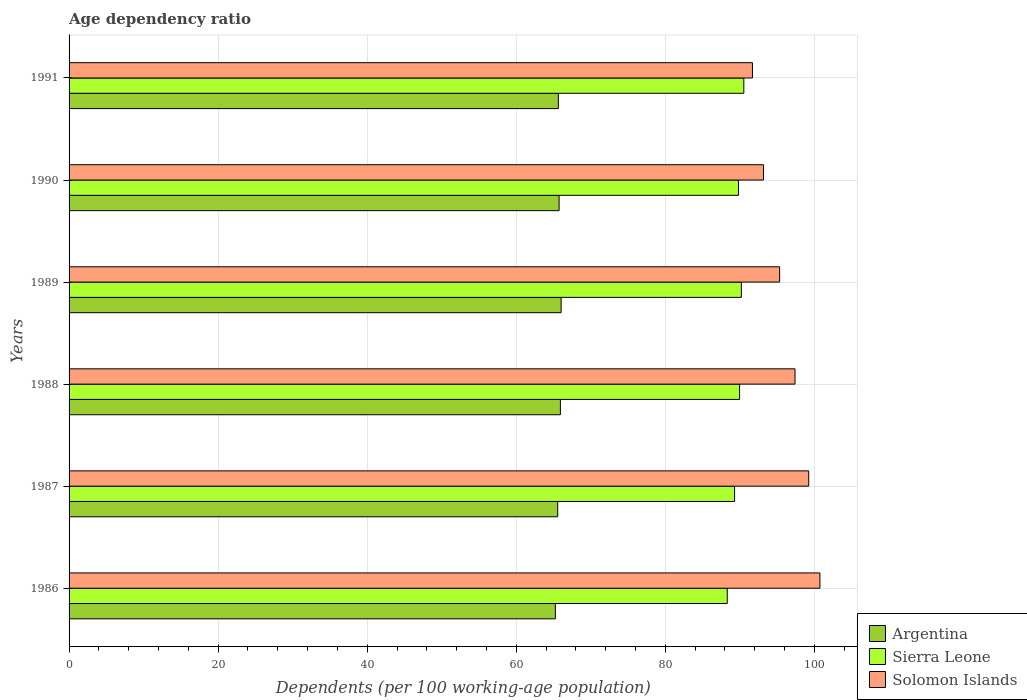How many different coloured bars are there?
Your answer should be compact. 3. How many groups of bars are there?
Ensure brevity in your answer.  6. Are the number of bars on each tick of the Y-axis equal?
Your answer should be compact. Yes. How many bars are there on the 2nd tick from the bottom?
Offer a terse response. 3. What is the label of the 3rd group of bars from the top?
Ensure brevity in your answer.  1989. What is the age dependency ratio in in Sierra Leone in 1990?
Offer a terse response. 89.81. Across all years, what is the maximum age dependency ratio in in Solomon Islands?
Offer a very short reply. 100.74. Across all years, what is the minimum age dependency ratio in in Argentina?
Offer a very short reply. 65.25. In which year was the age dependency ratio in in Sierra Leone minimum?
Provide a short and direct response. 1986. What is the total age dependency ratio in in Solomon Islands in the graph?
Your answer should be very brief. 577.56. What is the difference between the age dependency ratio in in Argentina in 1987 and that in 1990?
Your answer should be compact. -0.19. What is the difference between the age dependency ratio in in Argentina in 1990 and the age dependency ratio in in Sierra Leone in 1988?
Make the answer very short. -24.22. What is the average age dependency ratio in in Argentina per year?
Your answer should be compact. 65.69. In the year 1990, what is the difference between the age dependency ratio in in Argentina and age dependency ratio in in Solomon Islands?
Keep it short and to the point. -27.42. What is the ratio of the age dependency ratio in in Argentina in 1986 to that in 1990?
Provide a short and direct response. 0.99. What is the difference between the highest and the second highest age dependency ratio in in Argentina?
Your answer should be compact. 0.1. What is the difference between the highest and the lowest age dependency ratio in in Sierra Leone?
Keep it short and to the point. 2.22. Is the sum of the age dependency ratio in in Sierra Leone in 1987 and 1991 greater than the maximum age dependency ratio in in Solomon Islands across all years?
Ensure brevity in your answer.  Yes. What does the 2nd bar from the top in 1989 represents?
Your answer should be very brief. Sierra Leone. How many bars are there?
Give a very brief answer. 18. Are all the bars in the graph horizontal?
Provide a short and direct response. Yes. How many years are there in the graph?
Give a very brief answer. 6. What is the difference between two consecutive major ticks on the X-axis?
Ensure brevity in your answer.  20. Does the graph contain any zero values?
Provide a succinct answer. No. Does the graph contain grids?
Provide a short and direct response. Yes. Where does the legend appear in the graph?
Ensure brevity in your answer.  Bottom right. How many legend labels are there?
Give a very brief answer. 3. How are the legend labels stacked?
Give a very brief answer. Vertical. What is the title of the graph?
Your answer should be compact. Age dependency ratio. Does "Syrian Arab Republic" appear as one of the legend labels in the graph?
Your answer should be very brief. No. What is the label or title of the X-axis?
Your answer should be very brief. Dependents (per 100 working-age population). What is the Dependents (per 100 working-age population) in Argentina in 1986?
Your response must be concise. 65.25. What is the Dependents (per 100 working-age population) of Sierra Leone in 1986?
Make the answer very short. 88.3. What is the Dependents (per 100 working-age population) in Solomon Islands in 1986?
Your response must be concise. 100.74. What is the Dependents (per 100 working-age population) in Argentina in 1987?
Your answer should be compact. 65.56. What is the Dependents (per 100 working-age population) in Sierra Leone in 1987?
Offer a terse response. 89.29. What is the Dependents (per 100 working-age population) of Solomon Islands in 1987?
Provide a succinct answer. 99.23. What is the Dependents (per 100 working-age population) of Argentina in 1988?
Ensure brevity in your answer.  65.92. What is the Dependents (per 100 working-age population) in Sierra Leone in 1988?
Offer a very short reply. 89.96. What is the Dependents (per 100 working-age population) in Solomon Islands in 1988?
Ensure brevity in your answer.  97.4. What is the Dependents (per 100 working-age population) of Argentina in 1989?
Your response must be concise. 66.02. What is the Dependents (per 100 working-age population) of Sierra Leone in 1989?
Make the answer very short. 90.2. What is the Dependents (per 100 working-age population) of Solomon Islands in 1989?
Your answer should be compact. 95.33. What is the Dependents (per 100 working-age population) of Argentina in 1990?
Ensure brevity in your answer.  65.75. What is the Dependents (per 100 working-age population) in Sierra Leone in 1990?
Your answer should be compact. 89.81. What is the Dependents (per 100 working-age population) in Solomon Islands in 1990?
Your answer should be compact. 93.17. What is the Dependents (per 100 working-age population) in Argentina in 1991?
Your answer should be compact. 65.64. What is the Dependents (per 100 working-age population) in Sierra Leone in 1991?
Ensure brevity in your answer.  90.53. What is the Dependents (per 100 working-age population) of Solomon Islands in 1991?
Your response must be concise. 91.69. Across all years, what is the maximum Dependents (per 100 working-age population) of Argentina?
Provide a short and direct response. 66.02. Across all years, what is the maximum Dependents (per 100 working-age population) of Sierra Leone?
Your answer should be compact. 90.53. Across all years, what is the maximum Dependents (per 100 working-age population) of Solomon Islands?
Provide a short and direct response. 100.74. Across all years, what is the minimum Dependents (per 100 working-age population) in Argentina?
Your answer should be compact. 65.25. Across all years, what is the minimum Dependents (per 100 working-age population) in Sierra Leone?
Your answer should be very brief. 88.3. Across all years, what is the minimum Dependents (per 100 working-age population) in Solomon Islands?
Offer a very short reply. 91.69. What is the total Dependents (per 100 working-age population) in Argentina in the graph?
Provide a short and direct response. 394.13. What is the total Dependents (per 100 working-age population) of Sierra Leone in the graph?
Provide a short and direct response. 538.1. What is the total Dependents (per 100 working-age population) in Solomon Islands in the graph?
Make the answer very short. 577.56. What is the difference between the Dependents (per 100 working-age population) in Argentina in 1986 and that in 1987?
Make the answer very short. -0.31. What is the difference between the Dependents (per 100 working-age population) of Sierra Leone in 1986 and that in 1987?
Offer a terse response. -0.98. What is the difference between the Dependents (per 100 working-age population) in Solomon Islands in 1986 and that in 1987?
Your answer should be very brief. 1.5. What is the difference between the Dependents (per 100 working-age population) of Argentina in 1986 and that in 1988?
Offer a very short reply. -0.67. What is the difference between the Dependents (per 100 working-age population) in Sierra Leone in 1986 and that in 1988?
Provide a succinct answer. -1.66. What is the difference between the Dependents (per 100 working-age population) of Solomon Islands in 1986 and that in 1988?
Provide a succinct answer. 3.34. What is the difference between the Dependents (per 100 working-age population) of Argentina in 1986 and that in 1989?
Your answer should be very brief. -0.77. What is the difference between the Dependents (per 100 working-age population) in Sierra Leone in 1986 and that in 1989?
Make the answer very short. -1.89. What is the difference between the Dependents (per 100 working-age population) of Solomon Islands in 1986 and that in 1989?
Provide a succinct answer. 5.41. What is the difference between the Dependents (per 100 working-age population) of Argentina in 1986 and that in 1990?
Give a very brief answer. -0.5. What is the difference between the Dependents (per 100 working-age population) of Sierra Leone in 1986 and that in 1990?
Your answer should be very brief. -1.51. What is the difference between the Dependents (per 100 working-age population) of Solomon Islands in 1986 and that in 1990?
Offer a terse response. 7.57. What is the difference between the Dependents (per 100 working-age population) in Argentina in 1986 and that in 1991?
Give a very brief answer. -0.4. What is the difference between the Dependents (per 100 working-age population) in Sierra Leone in 1986 and that in 1991?
Keep it short and to the point. -2.22. What is the difference between the Dependents (per 100 working-age population) in Solomon Islands in 1986 and that in 1991?
Give a very brief answer. 9.05. What is the difference between the Dependents (per 100 working-age population) of Argentina in 1987 and that in 1988?
Provide a short and direct response. -0.36. What is the difference between the Dependents (per 100 working-age population) of Sierra Leone in 1987 and that in 1988?
Keep it short and to the point. -0.67. What is the difference between the Dependents (per 100 working-age population) in Solomon Islands in 1987 and that in 1988?
Make the answer very short. 1.84. What is the difference between the Dependents (per 100 working-age population) of Argentina in 1987 and that in 1989?
Provide a short and direct response. -0.46. What is the difference between the Dependents (per 100 working-age population) in Sierra Leone in 1987 and that in 1989?
Give a very brief answer. -0.91. What is the difference between the Dependents (per 100 working-age population) of Solomon Islands in 1987 and that in 1989?
Keep it short and to the point. 3.9. What is the difference between the Dependents (per 100 working-age population) of Argentina in 1987 and that in 1990?
Offer a very short reply. -0.19. What is the difference between the Dependents (per 100 working-age population) of Sierra Leone in 1987 and that in 1990?
Give a very brief answer. -0.52. What is the difference between the Dependents (per 100 working-age population) of Solomon Islands in 1987 and that in 1990?
Provide a succinct answer. 6.07. What is the difference between the Dependents (per 100 working-age population) of Argentina in 1987 and that in 1991?
Provide a succinct answer. -0.09. What is the difference between the Dependents (per 100 working-age population) of Sierra Leone in 1987 and that in 1991?
Your response must be concise. -1.24. What is the difference between the Dependents (per 100 working-age population) in Solomon Islands in 1987 and that in 1991?
Your response must be concise. 7.55. What is the difference between the Dependents (per 100 working-age population) in Argentina in 1988 and that in 1989?
Ensure brevity in your answer.  -0.1. What is the difference between the Dependents (per 100 working-age population) of Sierra Leone in 1988 and that in 1989?
Your answer should be compact. -0.24. What is the difference between the Dependents (per 100 working-age population) in Solomon Islands in 1988 and that in 1989?
Give a very brief answer. 2.07. What is the difference between the Dependents (per 100 working-age population) of Argentina in 1988 and that in 1990?
Your answer should be very brief. 0.17. What is the difference between the Dependents (per 100 working-age population) of Sierra Leone in 1988 and that in 1990?
Provide a succinct answer. 0.15. What is the difference between the Dependents (per 100 working-age population) in Solomon Islands in 1988 and that in 1990?
Offer a terse response. 4.23. What is the difference between the Dependents (per 100 working-age population) of Argentina in 1988 and that in 1991?
Make the answer very short. 0.27. What is the difference between the Dependents (per 100 working-age population) in Sierra Leone in 1988 and that in 1991?
Give a very brief answer. -0.57. What is the difference between the Dependents (per 100 working-age population) in Solomon Islands in 1988 and that in 1991?
Your response must be concise. 5.71. What is the difference between the Dependents (per 100 working-age population) of Argentina in 1989 and that in 1990?
Provide a short and direct response. 0.27. What is the difference between the Dependents (per 100 working-age population) of Sierra Leone in 1989 and that in 1990?
Your answer should be compact. 0.39. What is the difference between the Dependents (per 100 working-age population) of Solomon Islands in 1989 and that in 1990?
Your answer should be compact. 2.16. What is the difference between the Dependents (per 100 working-age population) in Argentina in 1989 and that in 1991?
Ensure brevity in your answer.  0.37. What is the difference between the Dependents (per 100 working-age population) in Sierra Leone in 1989 and that in 1991?
Offer a very short reply. -0.33. What is the difference between the Dependents (per 100 working-age population) in Solomon Islands in 1989 and that in 1991?
Offer a terse response. 3.65. What is the difference between the Dependents (per 100 working-age population) of Argentina in 1990 and that in 1991?
Provide a short and direct response. 0.1. What is the difference between the Dependents (per 100 working-age population) of Sierra Leone in 1990 and that in 1991?
Offer a very short reply. -0.72. What is the difference between the Dependents (per 100 working-age population) of Solomon Islands in 1990 and that in 1991?
Offer a very short reply. 1.48. What is the difference between the Dependents (per 100 working-age population) in Argentina in 1986 and the Dependents (per 100 working-age population) in Sierra Leone in 1987?
Offer a terse response. -24.04. What is the difference between the Dependents (per 100 working-age population) of Argentina in 1986 and the Dependents (per 100 working-age population) of Solomon Islands in 1987?
Your answer should be very brief. -33.99. What is the difference between the Dependents (per 100 working-age population) in Sierra Leone in 1986 and the Dependents (per 100 working-age population) in Solomon Islands in 1987?
Provide a succinct answer. -10.93. What is the difference between the Dependents (per 100 working-age population) in Argentina in 1986 and the Dependents (per 100 working-age population) in Sierra Leone in 1988?
Provide a short and direct response. -24.72. What is the difference between the Dependents (per 100 working-age population) in Argentina in 1986 and the Dependents (per 100 working-age population) in Solomon Islands in 1988?
Provide a short and direct response. -32.15. What is the difference between the Dependents (per 100 working-age population) in Sierra Leone in 1986 and the Dependents (per 100 working-age population) in Solomon Islands in 1988?
Your answer should be very brief. -9.09. What is the difference between the Dependents (per 100 working-age population) of Argentina in 1986 and the Dependents (per 100 working-age population) of Sierra Leone in 1989?
Make the answer very short. -24.95. What is the difference between the Dependents (per 100 working-age population) of Argentina in 1986 and the Dependents (per 100 working-age population) of Solomon Islands in 1989?
Keep it short and to the point. -30.09. What is the difference between the Dependents (per 100 working-age population) of Sierra Leone in 1986 and the Dependents (per 100 working-age population) of Solomon Islands in 1989?
Keep it short and to the point. -7.03. What is the difference between the Dependents (per 100 working-age population) of Argentina in 1986 and the Dependents (per 100 working-age population) of Sierra Leone in 1990?
Your response must be concise. -24.57. What is the difference between the Dependents (per 100 working-age population) of Argentina in 1986 and the Dependents (per 100 working-age population) of Solomon Islands in 1990?
Keep it short and to the point. -27.92. What is the difference between the Dependents (per 100 working-age population) in Sierra Leone in 1986 and the Dependents (per 100 working-age population) in Solomon Islands in 1990?
Make the answer very short. -4.86. What is the difference between the Dependents (per 100 working-age population) of Argentina in 1986 and the Dependents (per 100 working-age population) of Sierra Leone in 1991?
Your answer should be very brief. -25.28. What is the difference between the Dependents (per 100 working-age population) of Argentina in 1986 and the Dependents (per 100 working-age population) of Solomon Islands in 1991?
Keep it short and to the point. -26.44. What is the difference between the Dependents (per 100 working-age population) in Sierra Leone in 1986 and the Dependents (per 100 working-age population) in Solomon Islands in 1991?
Your answer should be compact. -3.38. What is the difference between the Dependents (per 100 working-age population) in Argentina in 1987 and the Dependents (per 100 working-age population) in Sierra Leone in 1988?
Offer a terse response. -24.4. What is the difference between the Dependents (per 100 working-age population) of Argentina in 1987 and the Dependents (per 100 working-age population) of Solomon Islands in 1988?
Your response must be concise. -31.84. What is the difference between the Dependents (per 100 working-age population) in Sierra Leone in 1987 and the Dependents (per 100 working-age population) in Solomon Islands in 1988?
Offer a very short reply. -8.11. What is the difference between the Dependents (per 100 working-age population) of Argentina in 1987 and the Dependents (per 100 working-age population) of Sierra Leone in 1989?
Make the answer very short. -24.64. What is the difference between the Dependents (per 100 working-age population) in Argentina in 1987 and the Dependents (per 100 working-age population) in Solomon Islands in 1989?
Offer a terse response. -29.77. What is the difference between the Dependents (per 100 working-age population) of Sierra Leone in 1987 and the Dependents (per 100 working-age population) of Solomon Islands in 1989?
Your answer should be compact. -6.04. What is the difference between the Dependents (per 100 working-age population) in Argentina in 1987 and the Dependents (per 100 working-age population) in Sierra Leone in 1990?
Your answer should be very brief. -24.25. What is the difference between the Dependents (per 100 working-age population) in Argentina in 1987 and the Dependents (per 100 working-age population) in Solomon Islands in 1990?
Your answer should be compact. -27.61. What is the difference between the Dependents (per 100 working-age population) in Sierra Leone in 1987 and the Dependents (per 100 working-age population) in Solomon Islands in 1990?
Ensure brevity in your answer.  -3.88. What is the difference between the Dependents (per 100 working-age population) of Argentina in 1987 and the Dependents (per 100 working-age population) of Sierra Leone in 1991?
Your answer should be compact. -24.97. What is the difference between the Dependents (per 100 working-age population) of Argentina in 1987 and the Dependents (per 100 working-age population) of Solomon Islands in 1991?
Ensure brevity in your answer.  -26.13. What is the difference between the Dependents (per 100 working-age population) in Sierra Leone in 1987 and the Dependents (per 100 working-age population) in Solomon Islands in 1991?
Give a very brief answer. -2.4. What is the difference between the Dependents (per 100 working-age population) in Argentina in 1988 and the Dependents (per 100 working-age population) in Sierra Leone in 1989?
Provide a succinct answer. -24.28. What is the difference between the Dependents (per 100 working-age population) of Argentina in 1988 and the Dependents (per 100 working-age population) of Solomon Islands in 1989?
Keep it short and to the point. -29.42. What is the difference between the Dependents (per 100 working-age population) of Sierra Leone in 1988 and the Dependents (per 100 working-age population) of Solomon Islands in 1989?
Offer a terse response. -5.37. What is the difference between the Dependents (per 100 working-age population) in Argentina in 1988 and the Dependents (per 100 working-age population) in Sierra Leone in 1990?
Your answer should be compact. -23.89. What is the difference between the Dependents (per 100 working-age population) in Argentina in 1988 and the Dependents (per 100 working-age population) in Solomon Islands in 1990?
Make the answer very short. -27.25. What is the difference between the Dependents (per 100 working-age population) in Sierra Leone in 1988 and the Dependents (per 100 working-age population) in Solomon Islands in 1990?
Your answer should be compact. -3.21. What is the difference between the Dependents (per 100 working-age population) in Argentina in 1988 and the Dependents (per 100 working-age population) in Sierra Leone in 1991?
Provide a succinct answer. -24.61. What is the difference between the Dependents (per 100 working-age population) of Argentina in 1988 and the Dependents (per 100 working-age population) of Solomon Islands in 1991?
Your response must be concise. -25.77. What is the difference between the Dependents (per 100 working-age population) in Sierra Leone in 1988 and the Dependents (per 100 working-age population) in Solomon Islands in 1991?
Your answer should be compact. -1.72. What is the difference between the Dependents (per 100 working-age population) of Argentina in 1989 and the Dependents (per 100 working-age population) of Sierra Leone in 1990?
Your response must be concise. -23.79. What is the difference between the Dependents (per 100 working-age population) in Argentina in 1989 and the Dependents (per 100 working-age population) in Solomon Islands in 1990?
Your response must be concise. -27.15. What is the difference between the Dependents (per 100 working-age population) of Sierra Leone in 1989 and the Dependents (per 100 working-age population) of Solomon Islands in 1990?
Your answer should be very brief. -2.97. What is the difference between the Dependents (per 100 working-age population) of Argentina in 1989 and the Dependents (per 100 working-age population) of Sierra Leone in 1991?
Give a very brief answer. -24.51. What is the difference between the Dependents (per 100 working-age population) in Argentina in 1989 and the Dependents (per 100 working-age population) in Solomon Islands in 1991?
Offer a very short reply. -25.67. What is the difference between the Dependents (per 100 working-age population) of Sierra Leone in 1989 and the Dependents (per 100 working-age population) of Solomon Islands in 1991?
Provide a short and direct response. -1.49. What is the difference between the Dependents (per 100 working-age population) of Argentina in 1990 and the Dependents (per 100 working-age population) of Sierra Leone in 1991?
Your answer should be very brief. -24.78. What is the difference between the Dependents (per 100 working-age population) of Argentina in 1990 and the Dependents (per 100 working-age population) of Solomon Islands in 1991?
Your answer should be compact. -25.94. What is the difference between the Dependents (per 100 working-age population) of Sierra Leone in 1990 and the Dependents (per 100 working-age population) of Solomon Islands in 1991?
Provide a succinct answer. -1.87. What is the average Dependents (per 100 working-age population) in Argentina per year?
Offer a very short reply. 65.69. What is the average Dependents (per 100 working-age population) in Sierra Leone per year?
Offer a very short reply. 89.68. What is the average Dependents (per 100 working-age population) in Solomon Islands per year?
Your answer should be compact. 96.26. In the year 1986, what is the difference between the Dependents (per 100 working-age population) in Argentina and Dependents (per 100 working-age population) in Sierra Leone?
Your answer should be very brief. -23.06. In the year 1986, what is the difference between the Dependents (per 100 working-age population) of Argentina and Dependents (per 100 working-age population) of Solomon Islands?
Your answer should be very brief. -35.49. In the year 1986, what is the difference between the Dependents (per 100 working-age population) of Sierra Leone and Dependents (per 100 working-age population) of Solomon Islands?
Keep it short and to the point. -12.43. In the year 1987, what is the difference between the Dependents (per 100 working-age population) of Argentina and Dependents (per 100 working-age population) of Sierra Leone?
Keep it short and to the point. -23.73. In the year 1987, what is the difference between the Dependents (per 100 working-age population) of Argentina and Dependents (per 100 working-age population) of Solomon Islands?
Offer a terse response. -33.68. In the year 1987, what is the difference between the Dependents (per 100 working-age population) in Sierra Leone and Dependents (per 100 working-age population) in Solomon Islands?
Provide a succinct answer. -9.95. In the year 1988, what is the difference between the Dependents (per 100 working-age population) in Argentina and Dependents (per 100 working-age population) in Sierra Leone?
Provide a short and direct response. -24.05. In the year 1988, what is the difference between the Dependents (per 100 working-age population) of Argentina and Dependents (per 100 working-age population) of Solomon Islands?
Offer a very short reply. -31.48. In the year 1988, what is the difference between the Dependents (per 100 working-age population) of Sierra Leone and Dependents (per 100 working-age population) of Solomon Islands?
Offer a terse response. -7.44. In the year 1989, what is the difference between the Dependents (per 100 working-age population) in Argentina and Dependents (per 100 working-age population) in Sierra Leone?
Your answer should be compact. -24.18. In the year 1989, what is the difference between the Dependents (per 100 working-age population) of Argentina and Dependents (per 100 working-age population) of Solomon Islands?
Ensure brevity in your answer.  -29.31. In the year 1989, what is the difference between the Dependents (per 100 working-age population) in Sierra Leone and Dependents (per 100 working-age population) in Solomon Islands?
Ensure brevity in your answer.  -5.13. In the year 1990, what is the difference between the Dependents (per 100 working-age population) of Argentina and Dependents (per 100 working-age population) of Sierra Leone?
Give a very brief answer. -24.07. In the year 1990, what is the difference between the Dependents (per 100 working-age population) in Argentina and Dependents (per 100 working-age population) in Solomon Islands?
Offer a very short reply. -27.42. In the year 1990, what is the difference between the Dependents (per 100 working-age population) of Sierra Leone and Dependents (per 100 working-age population) of Solomon Islands?
Offer a very short reply. -3.36. In the year 1991, what is the difference between the Dependents (per 100 working-age population) of Argentina and Dependents (per 100 working-age population) of Sierra Leone?
Give a very brief answer. -24.88. In the year 1991, what is the difference between the Dependents (per 100 working-age population) of Argentina and Dependents (per 100 working-age population) of Solomon Islands?
Give a very brief answer. -26.04. In the year 1991, what is the difference between the Dependents (per 100 working-age population) of Sierra Leone and Dependents (per 100 working-age population) of Solomon Islands?
Your response must be concise. -1.16. What is the ratio of the Dependents (per 100 working-age population) in Argentina in 1986 to that in 1987?
Make the answer very short. 1. What is the ratio of the Dependents (per 100 working-age population) in Sierra Leone in 1986 to that in 1987?
Your answer should be very brief. 0.99. What is the ratio of the Dependents (per 100 working-age population) of Solomon Islands in 1986 to that in 1987?
Offer a very short reply. 1.02. What is the ratio of the Dependents (per 100 working-age population) of Argentina in 1986 to that in 1988?
Ensure brevity in your answer.  0.99. What is the ratio of the Dependents (per 100 working-age population) of Sierra Leone in 1986 to that in 1988?
Keep it short and to the point. 0.98. What is the ratio of the Dependents (per 100 working-age population) in Solomon Islands in 1986 to that in 1988?
Your response must be concise. 1.03. What is the ratio of the Dependents (per 100 working-age population) in Argentina in 1986 to that in 1989?
Your response must be concise. 0.99. What is the ratio of the Dependents (per 100 working-age population) in Solomon Islands in 1986 to that in 1989?
Keep it short and to the point. 1.06. What is the ratio of the Dependents (per 100 working-age population) of Argentina in 1986 to that in 1990?
Your answer should be compact. 0.99. What is the ratio of the Dependents (per 100 working-age population) of Sierra Leone in 1986 to that in 1990?
Offer a very short reply. 0.98. What is the ratio of the Dependents (per 100 working-age population) in Solomon Islands in 1986 to that in 1990?
Offer a very short reply. 1.08. What is the ratio of the Dependents (per 100 working-age population) of Argentina in 1986 to that in 1991?
Your answer should be compact. 0.99. What is the ratio of the Dependents (per 100 working-age population) of Sierra Leone in 1986 to that in 1991?
Your answer should be very brief. 0.98. What is the ratio of the Dependents (per 100 working-age population) of Solomon Islands in 1986 to that in 1991?
Your answer should be very brief. 1.1. What is the ratio of the Dependents (per 100 working-age population) of Argentina in 1987 to that in 1988?
Provide a succinct answer. 0.99. What is the ratio of the Dependents (per 100 working-age population) of Sierra Leone in 1987 to that in 1988?
Your answer should be very brief. 0.99. What is the ratio of the Dependents (per 100 working-age population) in Solomon Islands in 1987 to that in 1988?
Give a very brief answer. 1.02. What is the ratio of the Dependents (per 100 working-age population) of Argentina in 1987 to that in 1989?
Your answer should be compact. 0.99. What is the ratio of the Dependents (per 100 working-age population) of Sierra Leone in 1987 to that in 1989?
Ensure brevity in your answer.  0.99. What is the ratio of the Dependents (per 100 working-age population) in Solomon Islands in 1987 to that in 1989?
Your response must be concise. 1.04. What is the ratio of the Dependents (per 100 working-age population) of Argentina in 1987 to that in 1990?
Make the answer very short. 1. What is the ratio of the Dependents (per 100 working-age population) in Sierra Leone in 1987 to that in 1990?
Your answer should be very brief. 0.99. What is the ratio of the Dependents (per 100 working-age population) in Solomon Islands in 1987 to that in 1990?
Provide a short and direct response. 1.07. What is the ratio of the Dependents (per 100 working-age population) of Argentina in 1987 to that in 1991?
Offer a terse response. 1. What is the ratio of the Dependents (per 100 working-age population) of Sierra Leone in 1987 to that in 1991?
Make the answer very short. 0.99. What is the ratio of the Dependents (per 100 working-age population) of Solomon Islands in 1987 to that in 1991?
Offer a very short reply. 1.08. What is the ratio of the Dependents (per 100 working-age population) in Solomon Islands in 1988 to that in 1989?
Offer a terse response. 1.02. What is the ratio of the Dependents (per 100 working-age population) of Sierra Leone in 1988 to that in 1990?
Your answer should be very brief. 1. What is the ratio of the Dependents (per 100 working-age population) in Solomon Islands in 1988 to that in 1990?
Provide a succinct answer. 1.05. What is the ratio of the Dependents (per 100 working-age population) of Argentina in 1988 to that in 1991?
Your answer should be compact. 1. What is the ratio of the Dependents (per 100 working-age population) of Sierra Leone in 1988 to that in 1991?
Your response must be concise. 0.99. What is the ratio of the Dependents (per 100 working-age population) in Solomon Islands in 1988 to that in 1991?
Make the answer very short. 1.06. What is the ratio of the Dependents (per 100 working-age population) in Argentina in 1989 to that in 1990?
Your answer should be very brief. 1. What is the ratio of the Dependents (per 100 working-age population) of Sierra Leone in 1989 to that in 1990?
Your answer should be compact. 1. What is the ratio of the Dependents (per 100 working-age population) in Solomon Islands in 1989 to that in 1990?
Ensure brevity in your answer.  1.02. What is the ratio of the Dependents (per 100 working-age population) of Argentina in 1989 to that in 1991?
Your answer should be compact. 1.01. What is the ratio of the Dependents (per 100 working-age population) of Sierra Leone in 1989 to that in 1991?
Your answer should be compact. 1. What is the ratio of the Dependents (per 100 working-age population) in Solomon Islands in 1989 to that in 1991?
Give a very brief answer. 1.04. What is the ratio of the Dependents (per 100 working-age population) in Argentina in 1990 to that in 1991?
Your response must be concise. 1. What is the ratio of the Dependents (per 100 working-age population) in Solomon Islands in 1990 to that in 1991?
Your response must be concise. 1.02. What is the difference between the highest and the second highest Dependents (per 100 working-age population) of Argentina?
Your answer should be very brief. 0.1. What is the difference between the highest and the second highest Dependents (per 100 working-age population) in Sierra Leone?
Ensure brevity in your answer.  0.33. What is the difference between the highest and the second highest Dependents (per 100 working-age population) of Solomon Islands?
Provide a succinct answer. 1.5. What is the difference between the highest and the lowest Dependents (per 100 working-age population) of Argentina?
Your answer should be very brief. 0.77. What is the difference between the highest and the lowest Dependents (per 100 working-age population) of Sierra Leone?
Provide a succinct answer. 2.22. What is the difference between the highest and the lowest Dependents (per 100 working-age population) in Solomon Islands?
Ensure brevity in your answer.  9.05. 